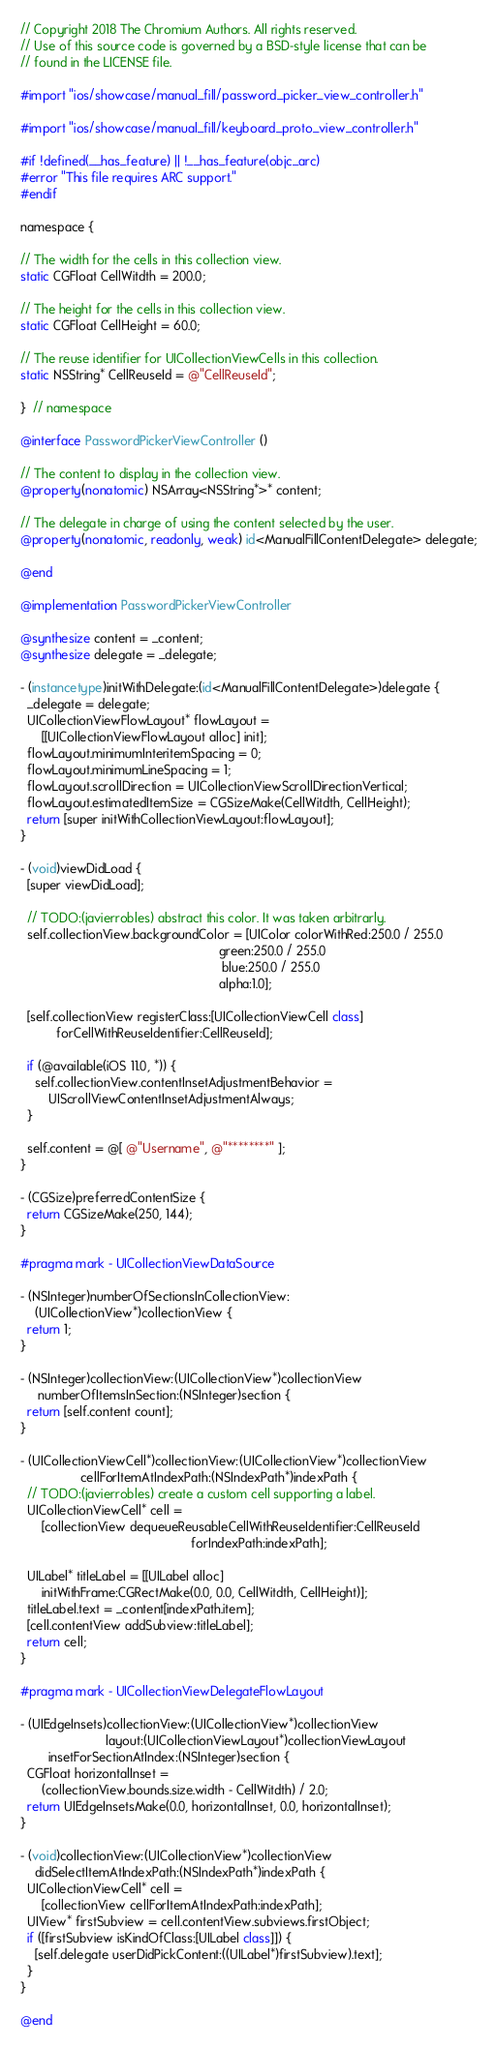<code> <loc_0><loc_0><loc_500><loc_500><_ObjectiveC_>// Copyright 2018 The Chromium Authors. All rights reserved.
// Use of this source code is governed by a BSD-style license that can be
// found in the LICENSE file.

#import "ios/showcase/manual_fill/password_picker_view_controller.h"

#import "ios/showcase/manual_fill/keyboard_proto_view_controller.h"

#if !defined(__has_feature) || !__has_feature(objc_arc)
#error "This file requires ARC support."
#endif

namespace {

// The width for the cells in this collection view.
static CGFloat CellWitdth = 200.0;

// The height for the cells in this collection view.
static CGFloat CellHeight = 60.0;

// The reuse identifier for UICollectionViewCells in this collection.
static NSString* CellReuseId = @"CellReuseId";

}  // namespace

@interface PasswordPickerViewController ()

// The content to display in the collection view.
@property(nonatomic) NSArray<NSString*>* content;

// The delegate in charge of using the content selected by the user.
@property(nonatomic, readonly, weak) id<ManualFillContentDelegate> delegate;

@end

@implementation PasswordPickerViewController

@synthesize content = _content;
@synthesize delegate = _delegate;

- (instancetype)initWithDelegate:(id<ManualFillContentDelegate>)delegate {
  _delegate = delegate;
  UICollectionViewFlowLayout* flowLayout =
      [[UICollectionViewFlowLayout alloc] init];
  flowLayout.minimumInteritemSpacing = 0;
  flowLayout.minimumLineSpacing = 1;
  flowLayout.scrollDirection = UICollectionViewScrollDirectionVertical;
  flowLayout.estimatedItemSize = CGSizeMake(CellWitdth, CellHeight);
  return [super initWithCollectionViewLayout:flowLayout];
}

- (void)viewDidLoad {
  [super viewDidLoad];

  // TODO:(javierrobles) abstract this color. It was taken arbitrarly.
  self.collectionView.backgroundColor = [UIColor colorWithRed:250.0 / 255.0
                                                        green:250.0 / 255.0
                                                         blue:250.0 / 255.0
                                                        alpha:1.0];

  [self.collectionView registerClass:[UICollectionViewCell class]
          forCellWithReuseIdentifier:CellReuseId];

  if (@available(iOS 11.0, *)) {
    self.collectionView.contentInsetAdjustmentBehavior =
        UIScrollViewContentInsetAdjustmentAlways;
  }

  self.content = @[ @"Username", @"********" ];
}

- (CGSize)preferredContentSize {
  return CGSizeMake(250, 144);
}

#pragma mark - UICollectionViewDataSource

- (NSInteger)numberOfSectionsInCollectionView:
    (UICollectionView*)collectionView {
  return 1;
}

- (NSInteger)collectionView:(UICollectionView*)collectionView
     numberOfItemsInSection:(NSInteger)section {
  return [self.content count];
}

- (UICollectionViewCell*)collectionView:(UICollectionView*)collectionView
                 cellForItemAtIndexPath:(NSIndexPath*)indexPath {
  // TODO:(javierrobles) create a custom cell supporting a label.
  UICollectionViewCell* cell =
      [collectionView dequeueReusableCellWithReuseIdentifier:CellReuseId
                                                forIndexPath:indexPath];

  UILabel* titleLabel = [[UILabel alloc]
      initWithFrame:CGRectMake(0.0, 0.0, CellWitdth, CellHeight)];
  titleLabel.text = _content[indexPath.item];
  [cell.contentView addSubview:titleLabel];
  return cell;
}

#pragma mark - UICollectionViewDelegateFlowLayout

- (UIEdgeInsets)collectionView:(UICollectionView*)collectionView
                        layout:(UICollectionViewLayout*)collectionViewLayout
        insetForSectionAtIndex:(NSInteger)section {
  CGFloat horizontalInset =
      (collectionView.bounds.size.width - CellWitdth) / 2.0;
  return UIEdgeInsetsMake(0.0, horizontalInset, 0.0, horizontalInset);
}

- (void)collectionView:(UICollectionView*)collectionView
    didSelectItemAtIndexPath:(NSIndexPath*)indexPath {
  UICollectionViewCell* cell =
      [collectionView cellForItemAtIndexPath:indexPath];
  UIView* firstSubview = cell.contentView.subviews.firstObject;
  if ([firstSubview isKindOfClass:[UILabel class]]) {
    [self.delegate userDidPickContent:((UILabel*)firstSubview).text];
  }
}

@end
</code> 